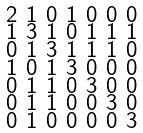Convert formula to latex. <formula><loc_0><loc_0><loc_500><loc_500>\begin{smallmatrix} 2 & 1 & 0 & 1 & 0 & 0 & 0 \\ 1 & 3 & 1 & 0 & 1 & 1 & 1 \\ 0 & 1 & 3 & 1 & 1 & 1 & 0 \\ 1 & 0 & 1 & 3 & 0 & 0 & 0 \\ 0 & 1 & 1 & 0 & 3 & 0 & 0 \\ 0 & 1 & 1 & 0 & 0 & 3 & 0 \\ 0 & 1 & 0 & 0 & 0 & 0 & 3 \end{smallmatrix}</formula> 